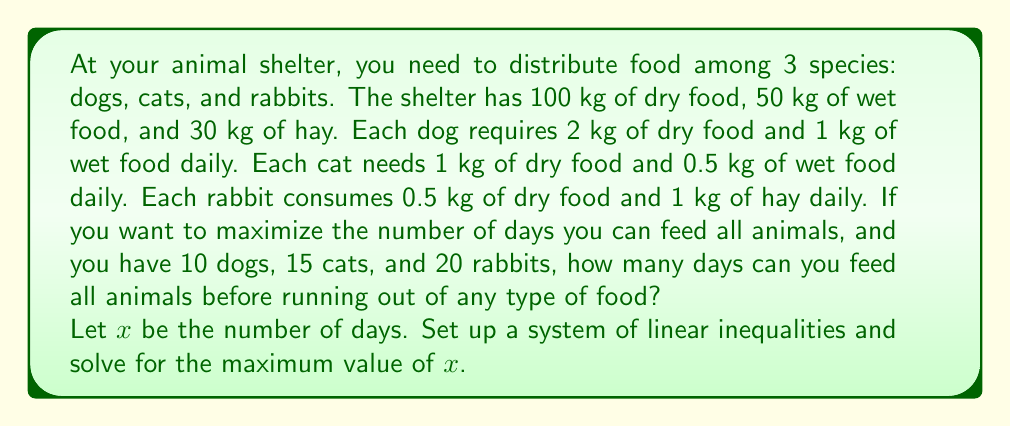What is the answer to this math problem? Let's approach this step-by-step:

1) First, let's set up the inequalities for each type of food:

   Dry food: $$(10 \cdot 2 + 15 \cdot 1 + 20 \cdot 0.5)x \leq 100$$
   Wet food: $$(10 \cdot 1 + 15 \cdot 0.5)x \leq 50$$
   Hay: $$(20 \cdot 1)x \leq 30$$

2) Simplify these inequalities:

   Dry food: $35x \leq 100$
   Wet food: $17.5x \leq 50$
   Hay: $20x \leq 30$

3) Now, solve each inequality for $x$:

   Dry food: $x \leq \frac{100}{35} \approx 2.86$
   Wet food: $x \leq \frac{50}{17.5} \approx 2.86$
   Hay: $x \leq \frac{30}{20} = 1.5$

4) The maximum number of days we can feed all animals is the smallest of these values, as that's when we'll first run out of a type of food.

5) The smallest value is 1.5, corresponding to the hay supply.

Therefore, you can feed all animals for a maximum of 1.5 days before running out of hay.
Answer: 1.5 days 